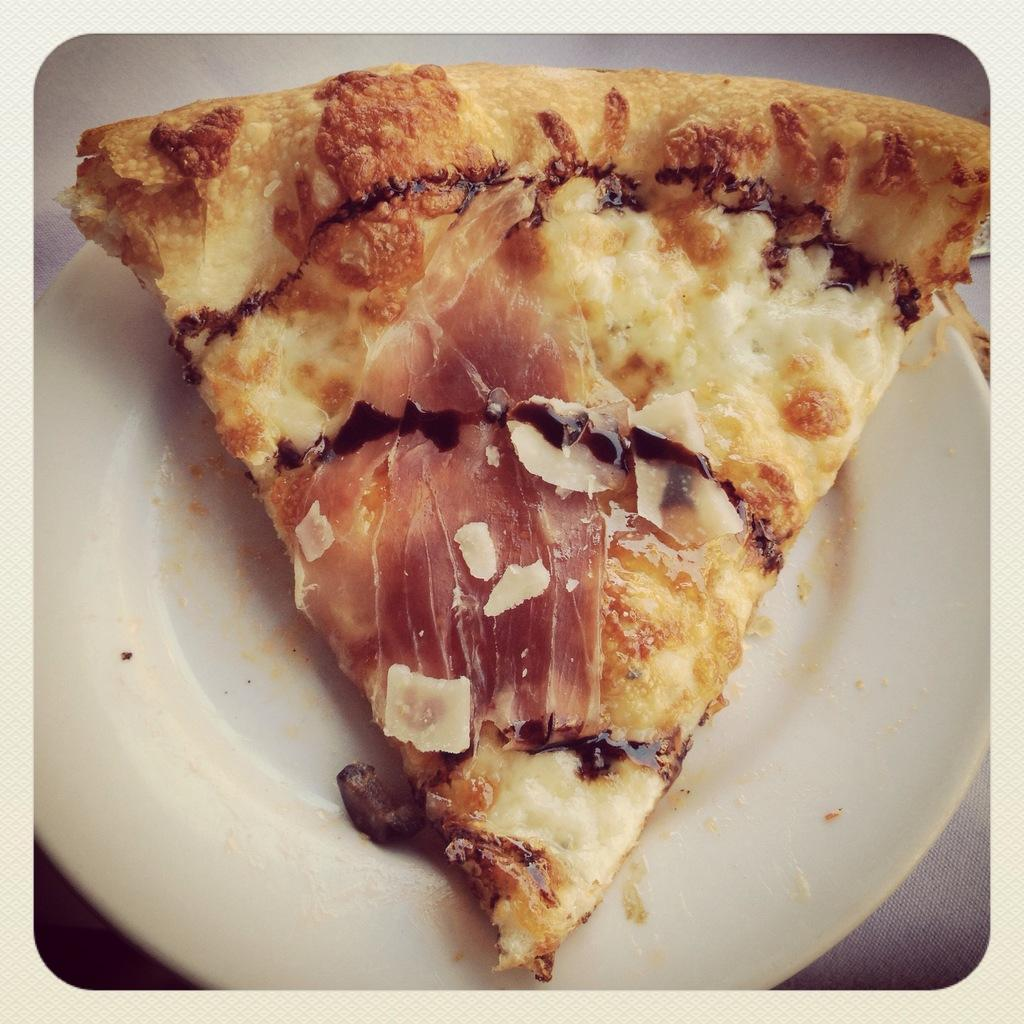What type of food is visible in the image? There is a pizza slice in a plate in the image. What type of sock is visible in the image? There is no sock present in the image. What type of scene is depicted in the image? The image does not depict a scene; it simply shows a pizza slice in a plate. 